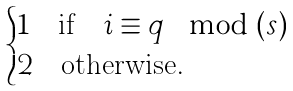Convert formula to latex. <formula><loc_0><loc_0><loc_500><loc_500>\begin{cases} 1 \quad \text {if} \quad i \equiv q \mod ( s ) \\ 2 \quad \text {otherwise} . \end{cases}</formula> 